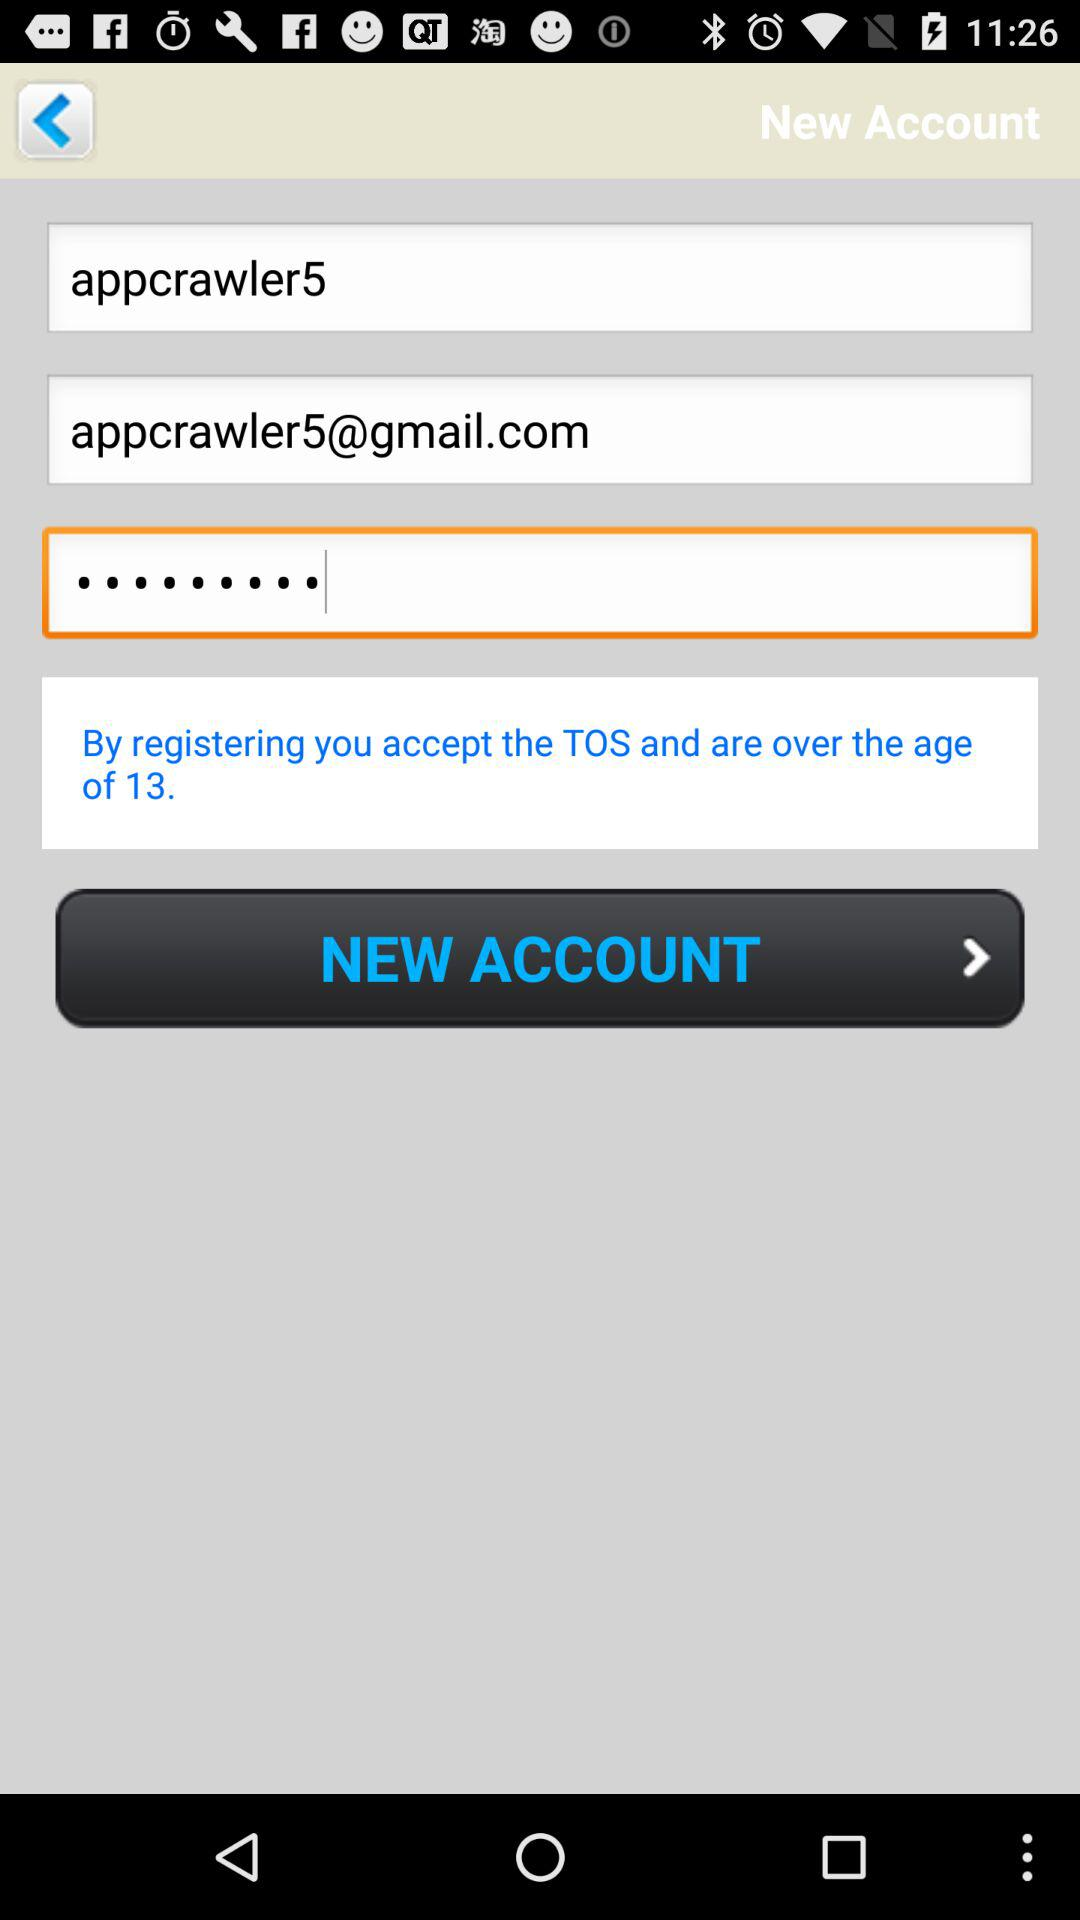What is the email address? The email address is appcrawler5@gmail.com. 